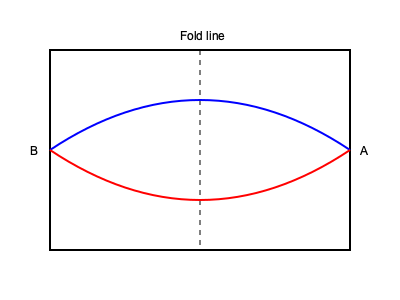An airplane safety instruction card is folded in half as shown in the diagram. When unfolded, which of the following statements is true about the blue curve (top) and the red curve (bottom)?

A) The blue curve will be above the red curve
B) The red curve will be above the blue curve
C) The curves will be mirror images of each other
D) The curves will intersect at multiple points To solve this problem, let's follow these steps:

1. Understand the folding process:
   - The card is folded along the vertical dashed line in the middle.
   - The left half (B) is folded over onto the right half (A).

2. Visualize the unfolding process:
   - When unfolded, the left half (B) will flip back to the left side.
   - This flipping action is equivalent to a reflection across the vertical fold line.

3. Analyze the curves:
   - The blue curve on the top half will remain in its current position.
   - The red curve on the bottom half will be reflected to the left side.

4. Compare the curves after unfolding:
   - The blue curve starts high on the left, dips in the middle, and ends high on the right.
   - The reflected red curve will start high on the right, dip in the middle, and end high on the left.

5. Determine the relationship between the curves:
   - After unfolding, the blue and red curves will be symmetrical about the vertical fold line.
   - They will form mirror images of each other.

Therefore, the correct statement is that the curves will be mirror images of each other.
Answer: C 